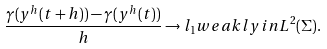Convert formula to latex. <formula><loc_0><loc_0><loc_500><loc_500>\frac { \gamma ( y ^ { h } ( t + h ) ) - \gamma ( y ^ { h } ( t ) ) } { h } \rightarrow l _ { 1 } w e a k l y i n L ^ { 2 } ( \Sigma ) .</formula> 